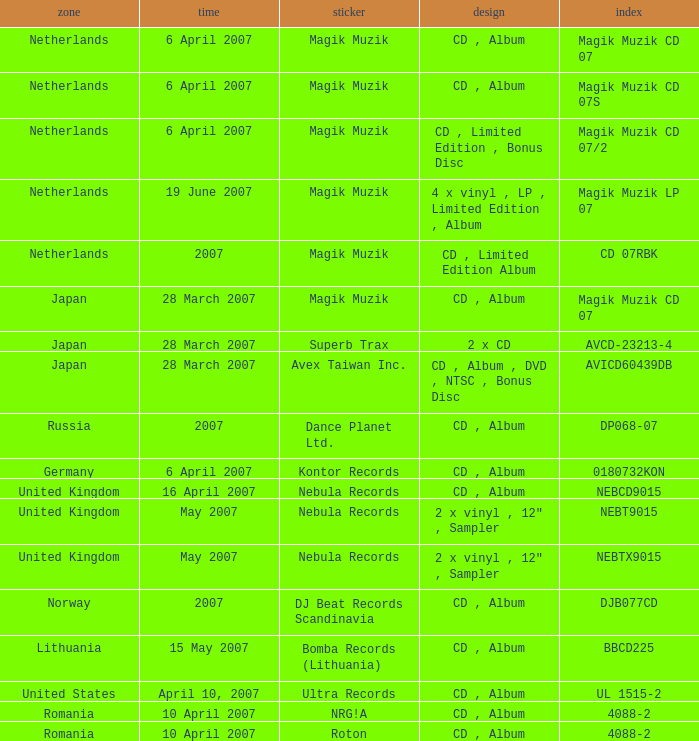From which region is the album with release date of 19 June 2007? Netherlands. 